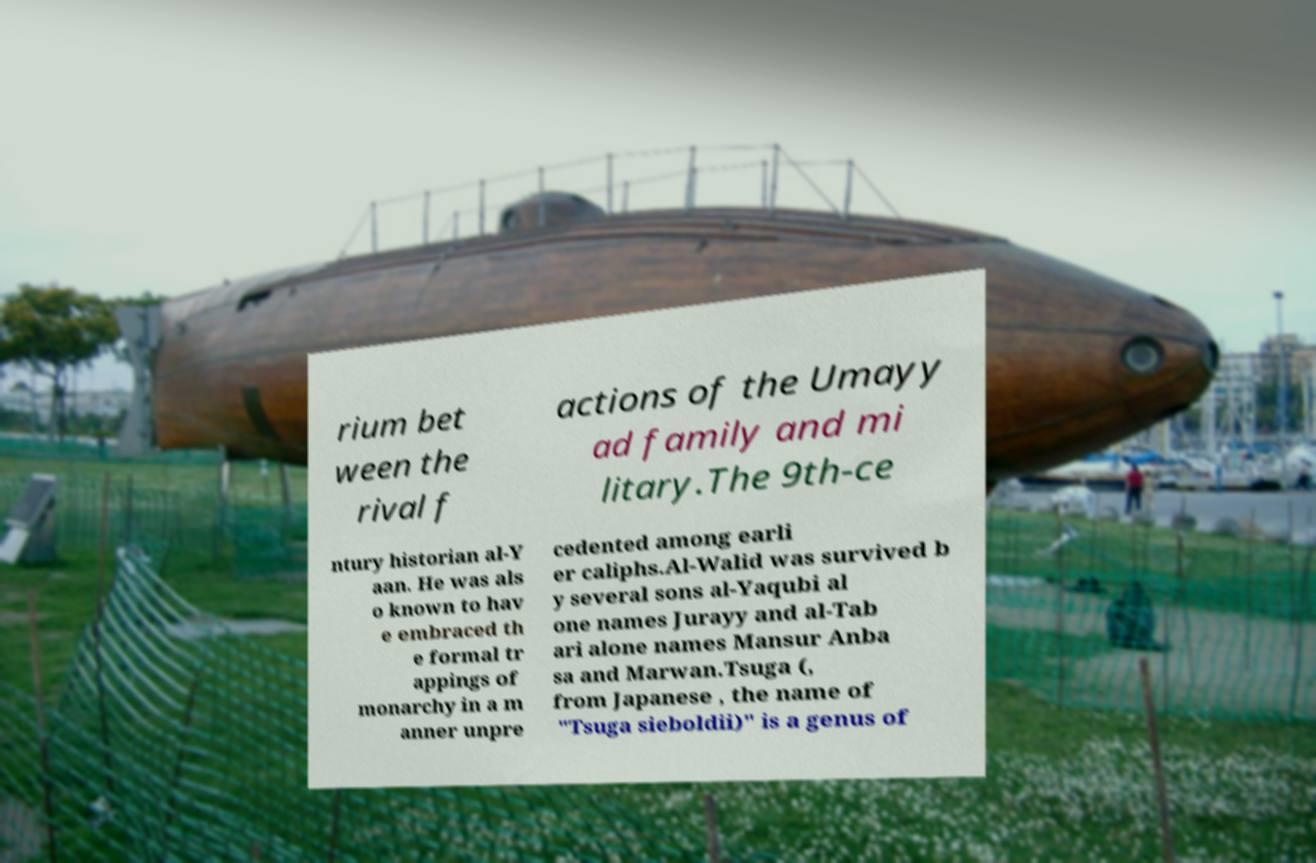I need the written content from this picture converted into text. Can you do that? rium bet ween the rival f actions of the Umayy ad family and mi litary.The 9th-ce ntury historian al-Y aan. He was als o known to hav e embraced th e formal tr appings of monarchy in a m anner unpre cedented among earli er caliphs.Al-Walid was survived b y several sons al-Yaqubi al one names Jurayy and al-Tab ari alone names Mansur Anba sa and Marwan.Tsuga (, from Japanese , the name of "Tsuga sieboldii)" is a genus of 